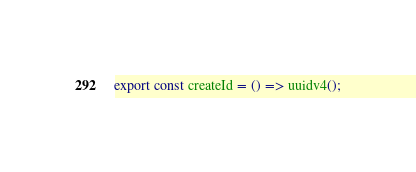Convert code to text. <code><loc_0><loc_0><loc_500><loc_500><_TypeScript_>export const createId = () => uuidv4();</code> 